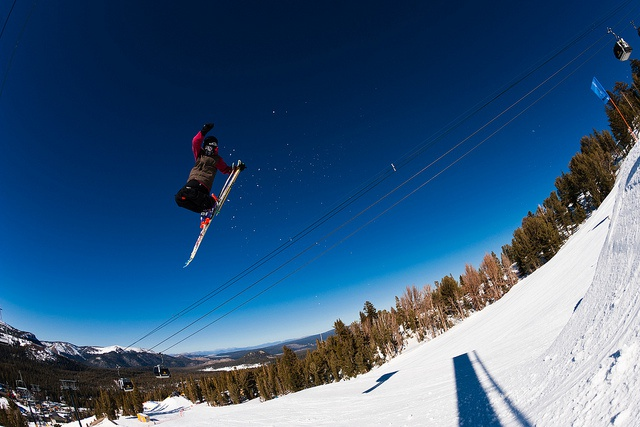Describe the objects in this image and their specific colors. I can see people in navy, black, maroon, and gray tones, snowboard in navy, black, blue, and lightgray tones, and skis in navy, lightgray, darkgray, and black tones in this image. 